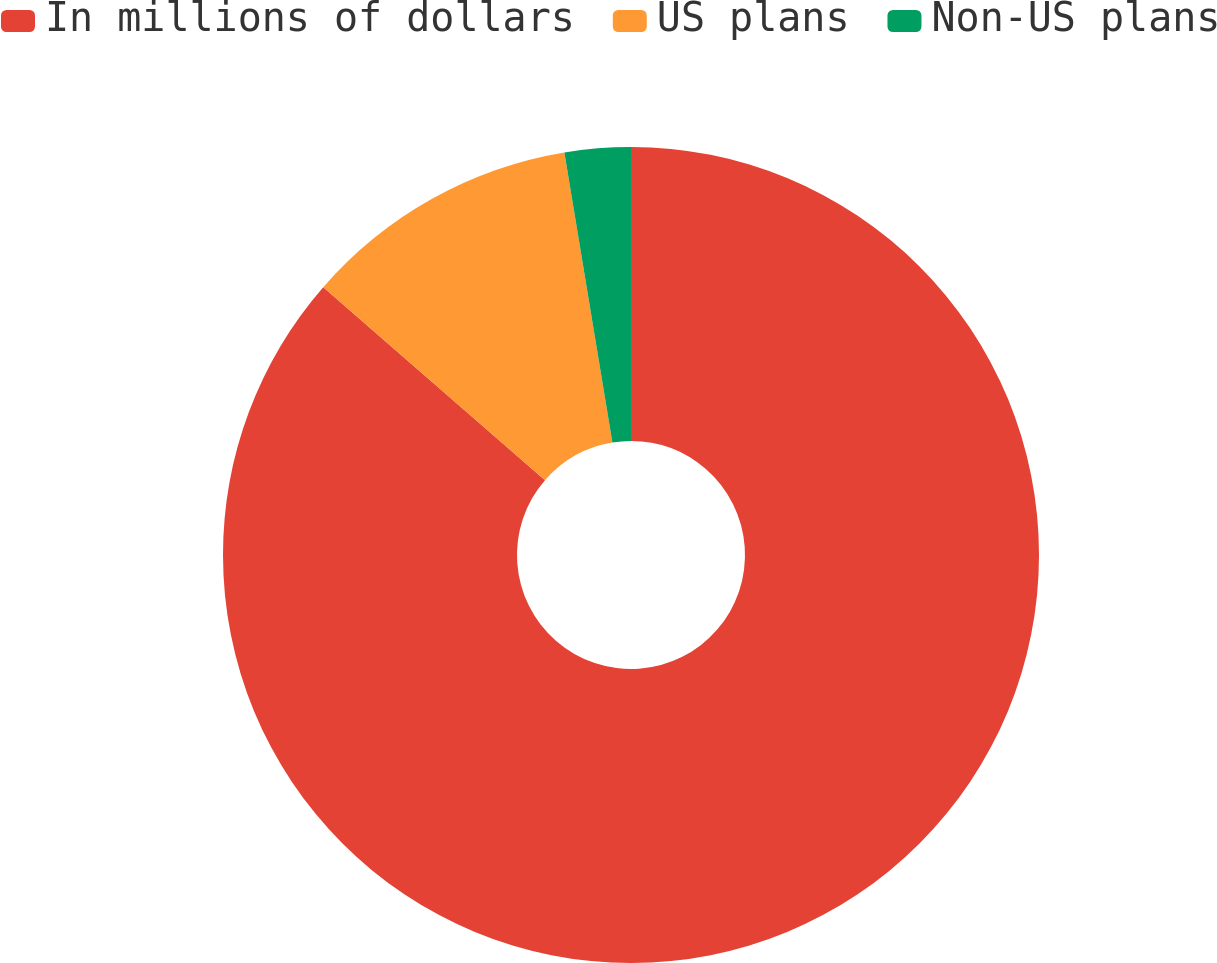Convert chart to OTSL. <chart><loc_0><loc_0><loc_500><loc_500><pie_chart><fcel>In millions of dollars<fcel>US plans<fcel>Non-US plans<nl><fcel>86.39%<fcel>10.99%<fcel>2.61%<nl></chart> 